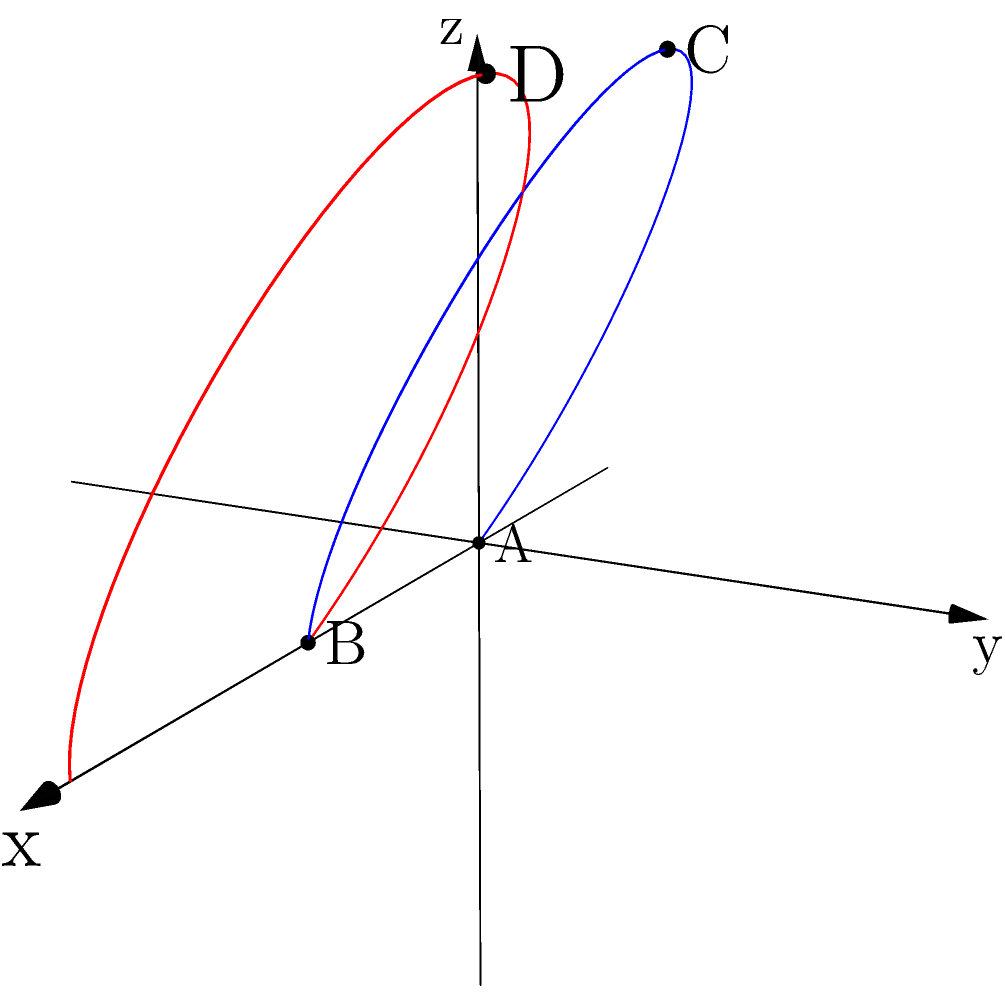In a badminton match, a shuttlecock follows a parabolic trajectory from point A(0,0,0) through point C(1,1,2) to point B(2,0,0) in a 3D coordinate system. If this trajectory is translated 2 units along the positive x-axis, what are the coordinates of point D, which corresponds to the translated position of point C? To solve this problem, we need to understand the concept of translation in 3D space:

1. Identify the original coordinates of point C: (1,1,2)

2. Determine the translation vector:
   The trajectory is translated 2 units along the positive x-axis, so the translation vector is (2,0,0)

3. Apply the translation to point C:
   - New x-coordinate: 1 + 2 = 3
   - y-coordinate remains unchanged: 1
   - z-coordinate remains unchanged: 2

4. Therefore, the coordinates of point D are (3,1,2)

This translation can be represented mathematically as:
$$(x,y,z) \rightarrow (x+2,y,z)$$

Or more generally:
$$(x,y,z) \rightarrow (x+a,y+b,z+c)$$

Where (a,b,c) is the translation vector, in this case (2,0,0).
Answer: (3,1,2) 